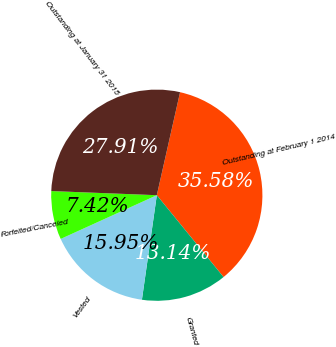<chart> <loc_0><loc_0><loc_500><loc_500><pie_chart><fcel>Outstanding at February 1 2014<fcel>Granted<fcel>Vested<fcel>Forfeited/Canceled<fcel>Outstanding at January 31 2015<nl><fcel>35.58%<fcel>13.14%<fcel>15.95%<fcel>7.42%<fcel>27.91%<nl></chart> 